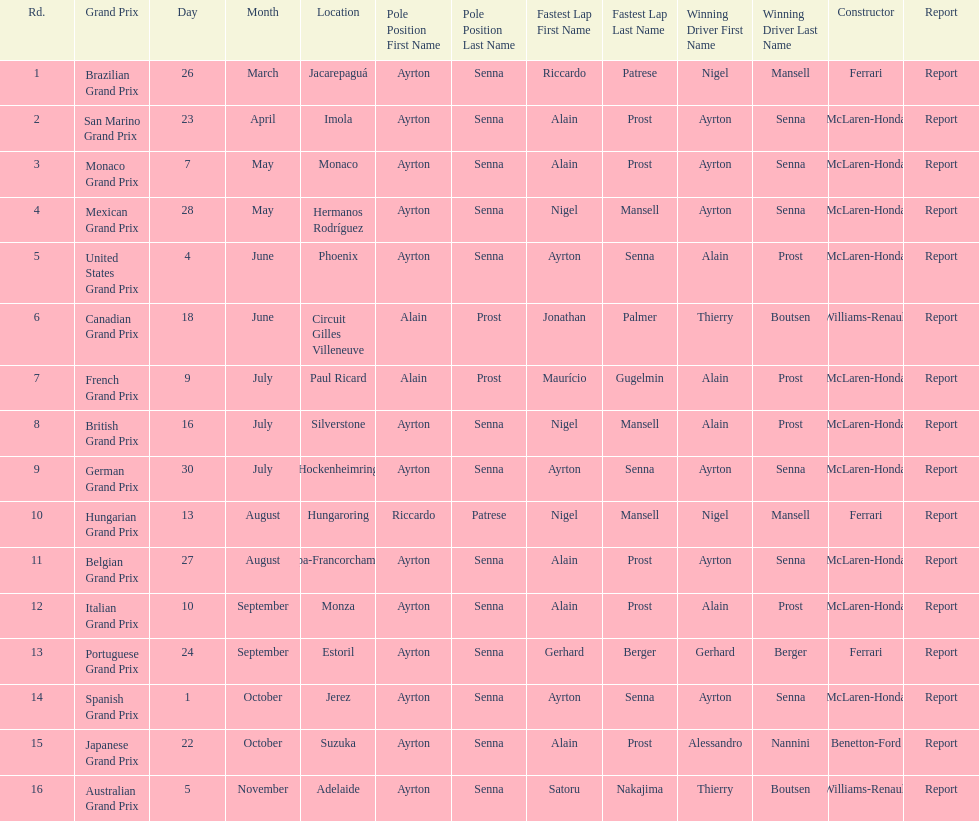How many races occurred before alain prost won a pole position? 5. 